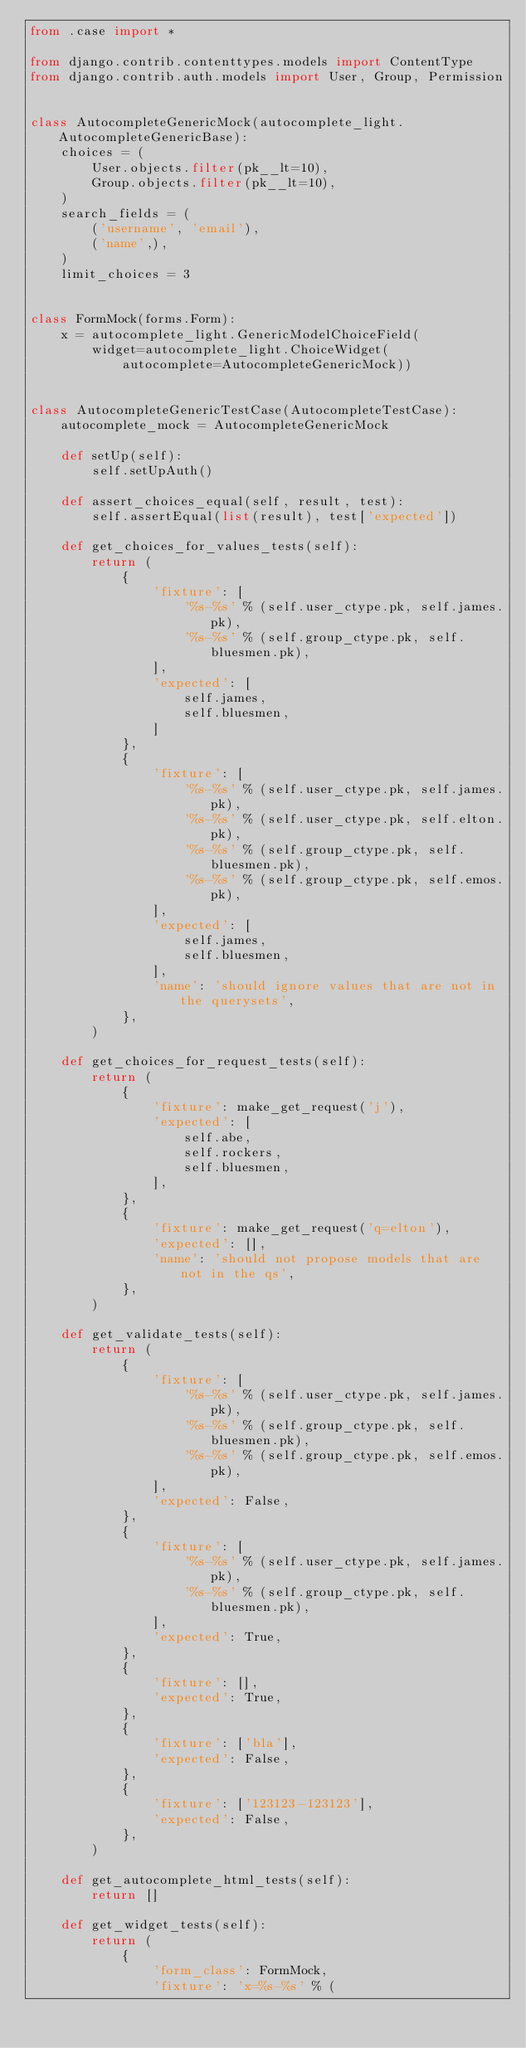<code> <loc_0><loc_0><loc_500><loc_500><_Python_>from .case import *

from django.contrib.contenttypes.models import ContentType
from django.contrib.auth.models import User, Group, Permission


class AutocompleteGenericMock(autocomplete_light.AutocompleteGenericBase):
    choices = (
        User.objects.filter(pk__lt=10),
        Group.objects.filter(pk__lt=10),
    )
    search_fields = (
        ('username', 'email'),
        ('name',),
    )
    limit_choices = 3


class FormMock(forms.Form):
    x = autocomplete_light.GenericModelChoiceField(
        widget=autocomplete_light.ChoiceWidget(
            autocomplete=AutocompleteGenericMock))


class AutocompleteGenericTestCase(AutocompleteTestCase):
    autocomplete_mock = AutocompleteGenericMock

    def setUp(self):
        self.setUpAuth()

    def assert_choices_equal(self, result, test):
        self.assertEqual(list(result), test['expected'])

    def get_choices_for_values_tests(self):
        return (
            {
                'fixture': [
                    '%s-%s' % (self.user_ctype.pk, self.james.pk),
                    '%s-%s' % (self.group_ctype.pk, self.bluesmen.pk),
                ],
                'expected': [
                    self.james,
                    self.bluesmen,
                ]
            },
            {
                'fixture': [
                    '%s-%s' % (self.user_ctype.pk, self.james.pk),
                    '%s-%s' % (self.user_ctype.pk, self.elton.pk),
                    '%s-%s' % (self.group_ctype.pk, self.bluesmen.pk),
                    '%s-%s' % (self.group_ctype.pk, self.emos.pk),
                ],
                'expected': [
                    self.james,
                    self.bluesmen,
                ],
                'name': 'should ignore values that are not in the querysets',
            },
        )

    def get_choices_for_request_tests(self):
        return (
            {
                'fixture': make_get_request('j'),
                'expected': [
                    self.abe,
                    self.rockers,
                    self.bluesmen,
                ],
            },
            {
                'fixture': make_get_request('q=elton'),
                'expected': [],
                'name': 'should not propose models that are not in the qs',
            },
        )

    def get_validate_tests(self):
        return (
            {
                'fixture': [
                    '%s-%s' % (self.user_ctype.pk, self.james.pk),
                    '%s-%s' % (self.group_ctype.pk, self.bluesmen.pk),
                    '%s-%s' % (self.group_ctype.pk, self.emos.pk),
                ],
                'expected': False,
            },
            {
                'fixture': [
                    '%s-%s' % (self.user_ctype.pk, self.james.pk),
                    '%s-%s' % (self.group_ctype.pk, self.bluesmen.pk),
                ],
                'expected': True,
            },
            {
                'fixture': [],
                'expected': True,
            },
            {
                'fixture': ['bla'],
                'expected': False,
            },
            {
                'fixture': ['123123-123123'],
                'expected': False,
            },
        )

    def get_autocomplete_html_tests(self):
        return []

    def get_widget_tests(self):
        return (
            {
                'form_class': FormMock,
                'fixture': 'x=%s-%s' % (</code> 